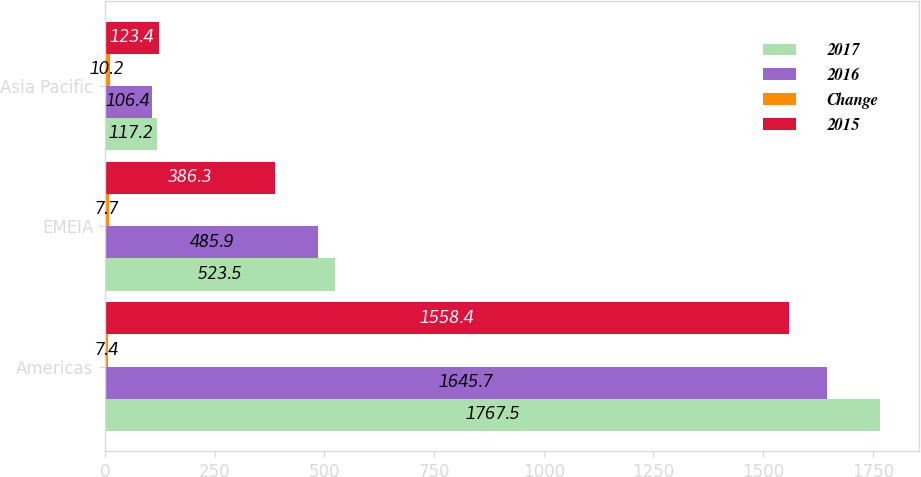Convert chart. <chart><loc_0><loc_0><loc_500><loc_500><stacked_bar_chart><ecel><fcel>Americas<fcel>EMEIA<fcel>Asia Pacific<nl><fcel>2017<fcel>1767.5<fcel>523.5<fcel>117.2<nl><fcel>2016<fcel>1645.7<fcel>485.9<fcel>106.4<nl><fcel>Change<fcel>7.4<fcel>7.7<fcel>10.2<nl><fcel>2015<fcel>1558.4<fcel>386.3<fcel>123.4<nl></chart> 